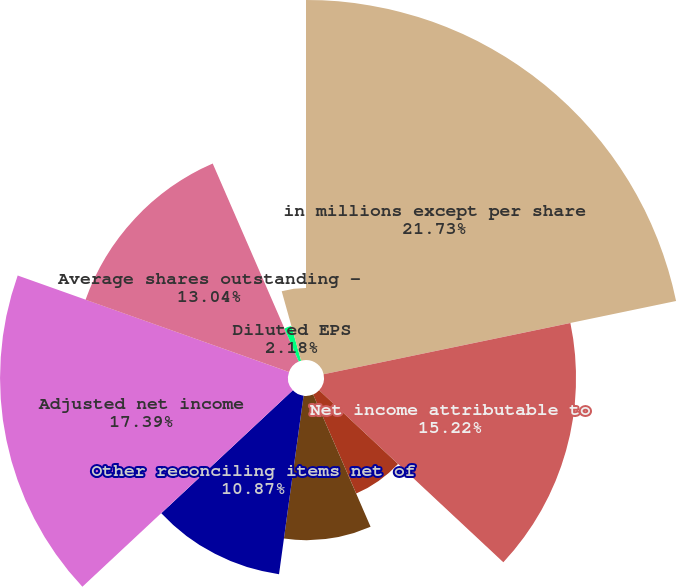Convert chart. <chart><loc_0><loc_0><loc_500><loc_500><pie_chart><fcel>in millions except per share<fcel>Net income attributable to<fcel>CIP eliminated upon<fcel>Acquisition/disposition<fcel>Deferred compensation plan<fcel>Other reconciling items net of<fcel>Adjusted net income<fcel>Average shares outstanding -<fcel>Diluted EPS<fcel>Adjusted diluted EPS<nl><fcel>21.74%<fcel>15.22%<fcel>6.52%<fcel>8.7%<fcel>0.0%<fcel>10.87%<fcel>17.39%<fcel>13.04%<fcel>2.18%<fcel>4.35%<nl></chart> 